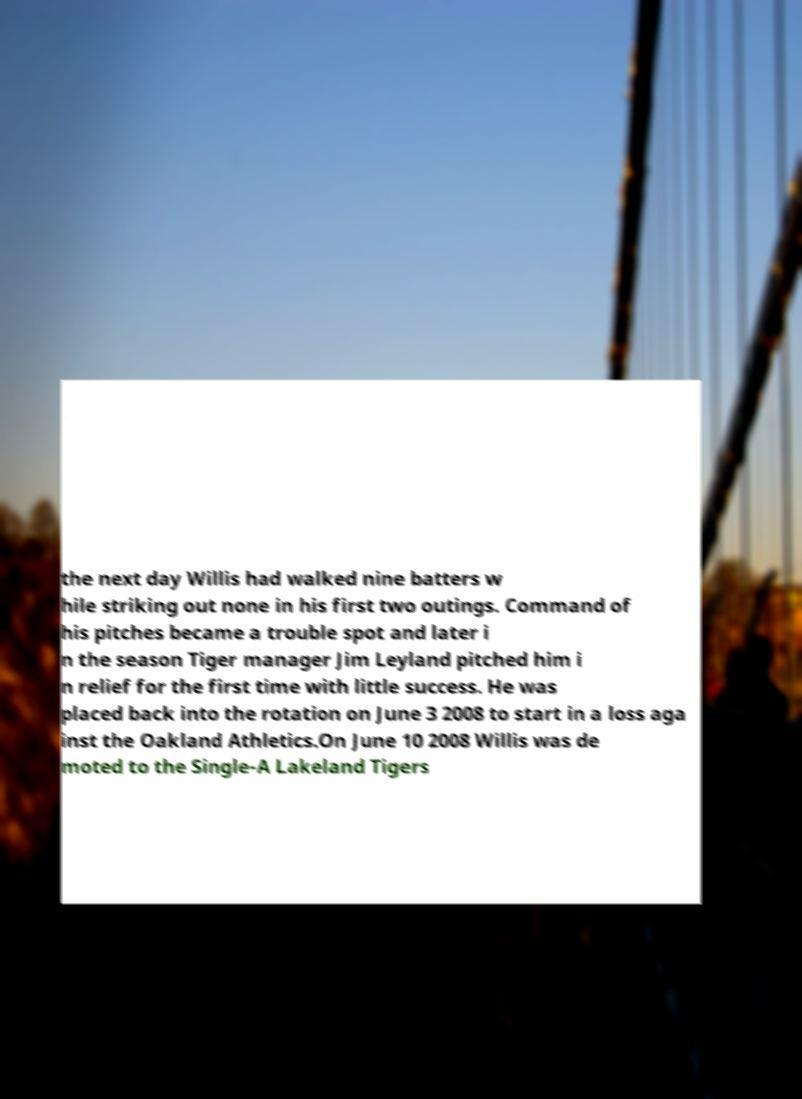For documentation purposes, I need the text within this image transcribed. Could you provide that? the next day Willis had walked nine batters w hile striking out none in his first two outings. Command of his pitches became a trouble spot and later i n the season Tiger manager Jim Leyland pitched him i n relief for the first time with little success. He was placed back into the rotation on June 3 2008 to start in a loss aga inst the Oakland Athletics.On June 10 2008 Willis was de moted to the Single-A Lakeland Tigers 